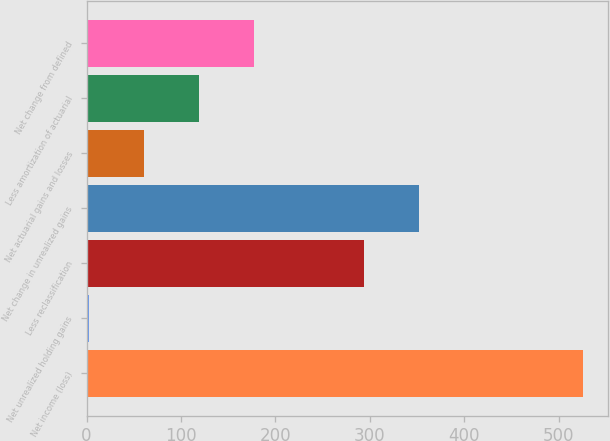Convert chart. <chart><loc_0><loc_0><loc_500><loc_500><bar_chart><fcel>Net income (loss)<fcel>Net unrealized holding gains<fcel>Less reclassification<fcel>Net change in unrealized gains<fcel>Net actuarial gains and losses<fcel>Less amortization of actuarial<fcel>Net change from defined<nl><fcel>525.9<fcel>3<fcel>293.5<fcel>351.6<fcel>61.1<fcel>119.2<fcel>177.3<nl></chart> 